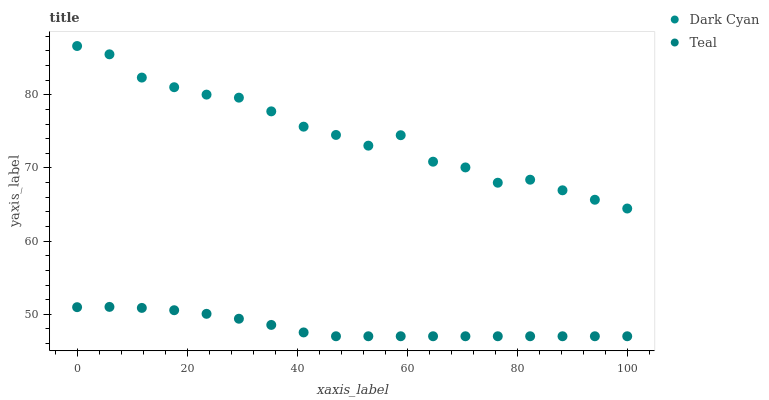Does Teal have the minimum area under the curve?
Answer yes or no. Yes. Does Dark Cyan have the maximum area under the curve?
Answer yes or no. Yes. Does Teal have the maximum area under the curve?
Answer yes or no. No. Is Teal the smoothest?
Answer yes or no. Yes. Is Dark Cyan the roughest?
Answer yes or no. Yes. Is Teal the roughest?
Answer yes or no. No. Does Teal have the lowest value?
Answer yes or no. Yes. Does Dark Cyan have the highest value?
Answer yes or no. Yes. Does Teal have the highest value?
Answer yes or no. No. Is Teal less than Dark Cyan?
Answer yes or no. Yes. Is Dark Cyan greater than Teal?
Answer yes or no. Yes. Does Teal intersect Dark Cyan?
Answer yes or no. No. 